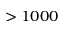Convert formula to latex. <formula><loc_0><loc_0><loc_500><loc_500>> 1 0 0 0</formula> 